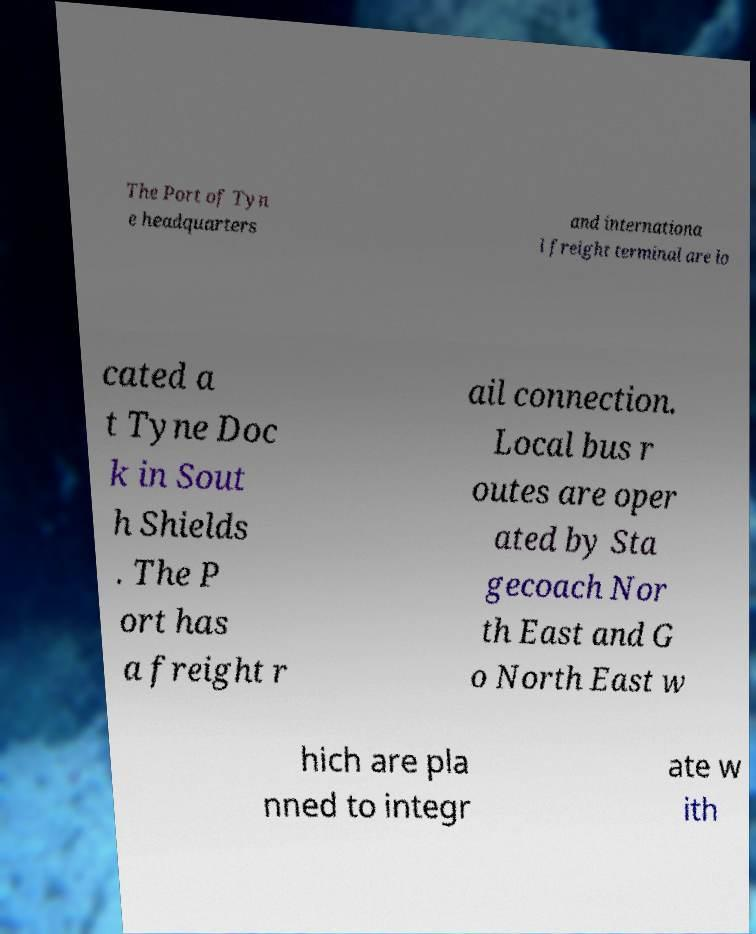Can you read and provide the text displayed in the image?This photo seems to have some interesting text. Can you extract and type it out for me? The Port of Tyn e headquarters and internationa l freight terminal are lo cated a t Tyne Doc k in Sout h Shields . The P ort has a freight r ail connection. Local bus r outes are oper ated by Sta gecoach Nor th East and G o North East w hich are pla nned to integr ate w ith 